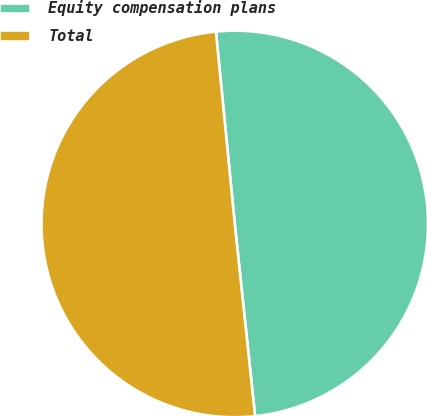Convert chart to OTSL. <chart><loc_0><loc_0><loc_500><loc_500><pie_chart><fcel>Equity compensation plans<fcel>Total<nl><fcel>49.88%<fcel>50.12%<nl></chart> 